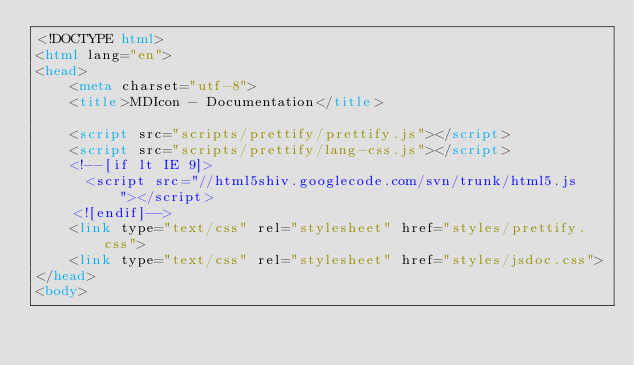Convert code to text. <code><loc_0><loc_0><loc_500><loc_500><_HTML_><!DOCTYPE html>
<html lang="en">
<head>
    <meta charset="utf-8">
    <title>MDIcon - Documentation</title>

    <script src="scripts/prettify/prettify.js"></script>
    <script src="scripts/prettify/lang-css.js"></script>
    <!--[if lt IE 9]>
      <script src="//html5shiv.googlecode.com/svn/trunk/html5.js"></script>
    <![endif]-->
    <link type="text/css" rel="stylesheet" href="styles/prettify.css">
    <link type="text/css" rel="stylesheet" href="styles/jsdoc.css">
</head>
<body>
</code> 